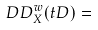Convert formula to latex. <formula><loc_0><loc_0><loc_500><loc_500>\ D D ^ { w } _ { X } ( t D ) =</formula> 